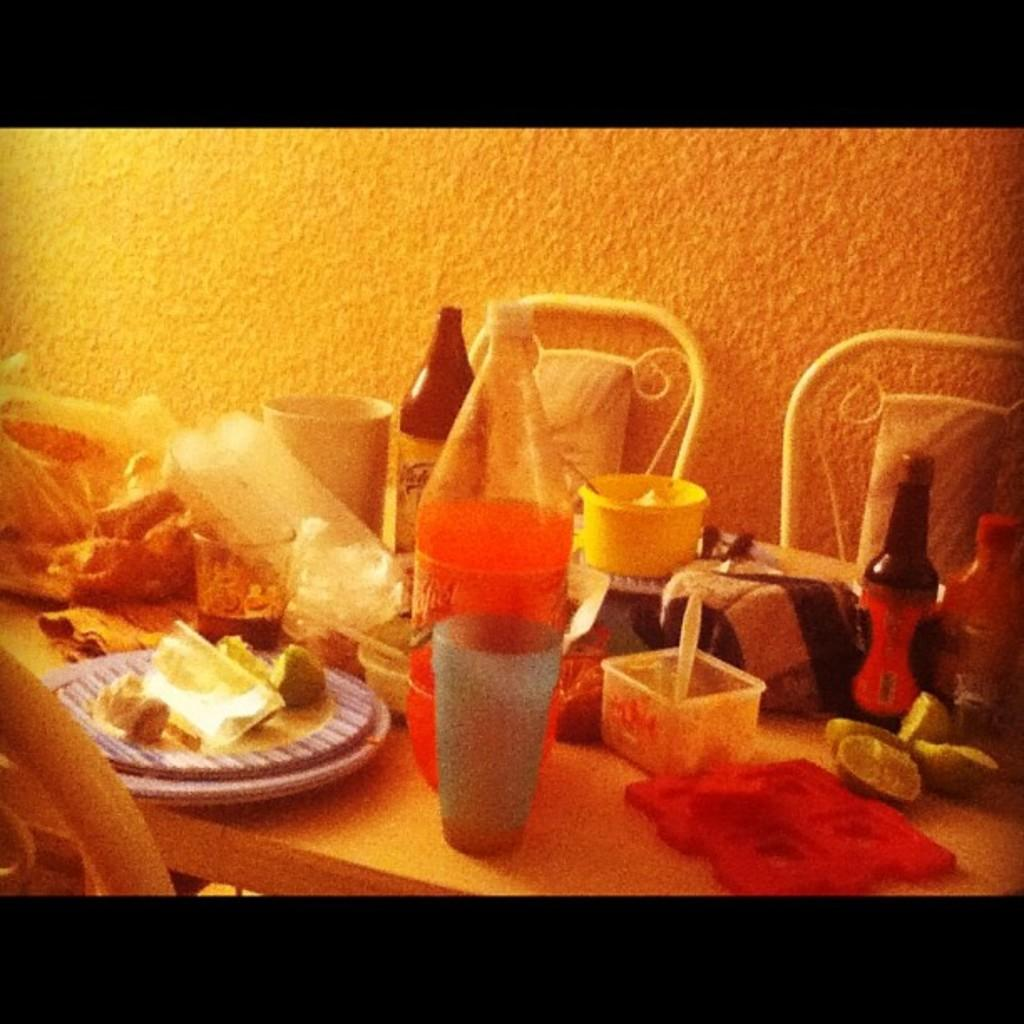What type of furniture is present in the image? There is a table and chairs in the image. What items can be seen on the table? There are bottles, glasses, and food items on the table. What is the background of the image? There is a wall visible in the image. What type of scissors can be seen cutting the word "harbor" in the image? There are no scissors or the word "harbor" present in the image. 